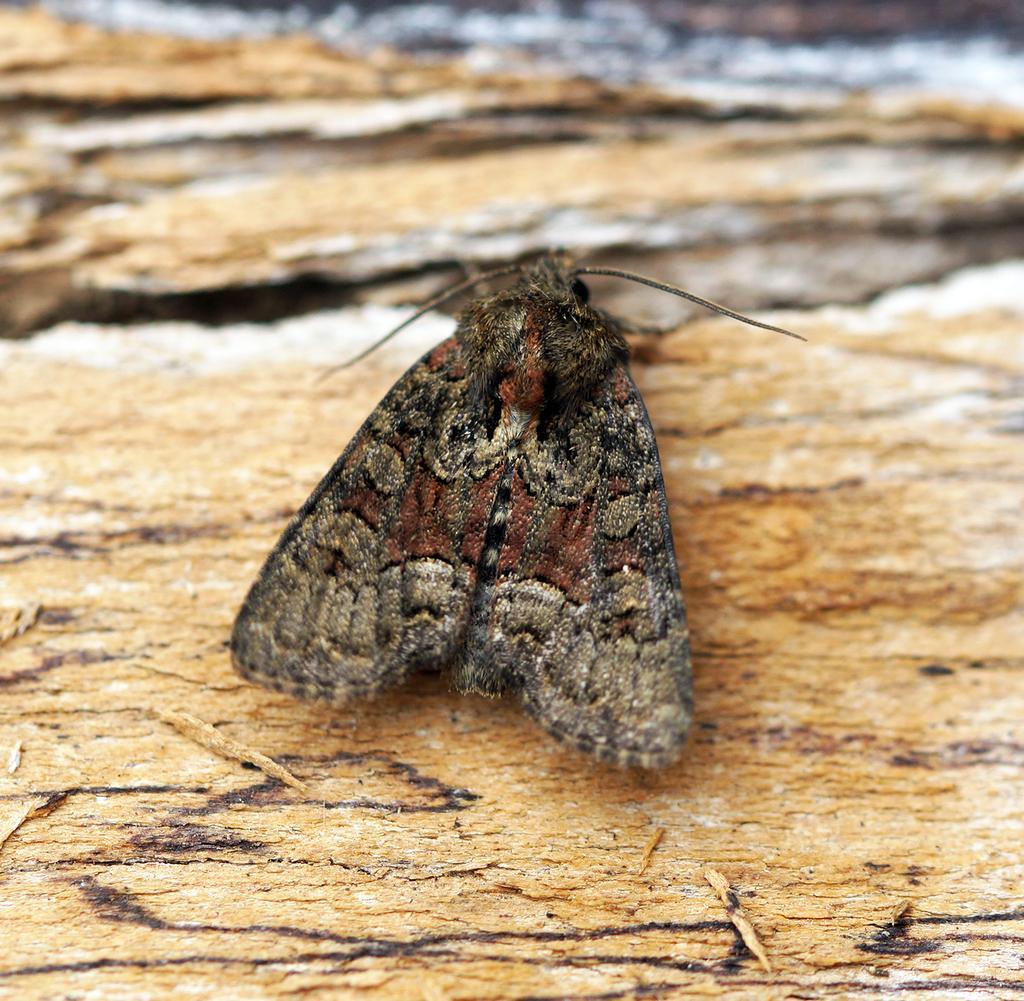How would you summarize this image in a sentence or two? In the image we can see a butterfly, wooden surface and the top part of the image is blurred. 